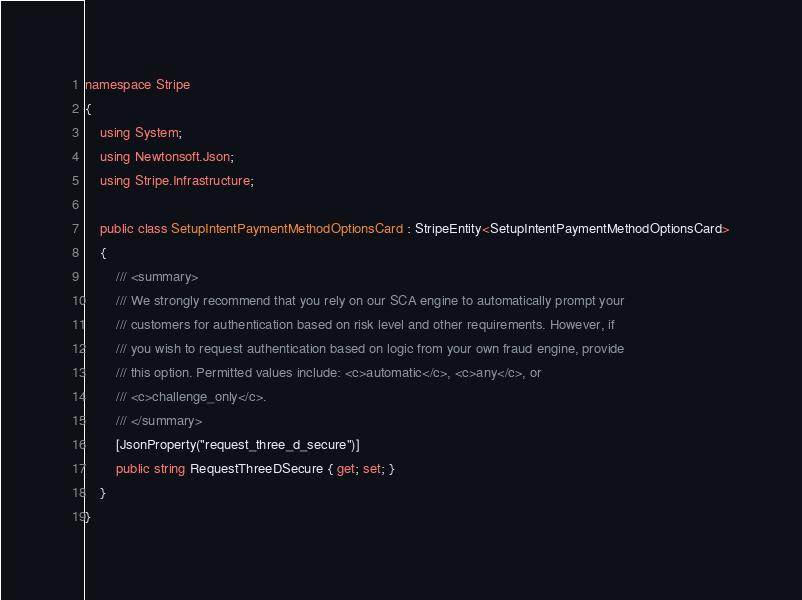<code> <loc_0><loc_0><loc_500><loc_500><_C#_>namespace Stripe
{
    using System;
    using Newtonsoft.Json;
    using Stripe.Infrastructure;

    public class SetupIntentPaymentMethodOptionsCard : StripeEntity<SetupIntentPaymentMethodOptionsCard>
    {
        /// <summary>
        /// We strongly recommend that you rely on our SCA engine to automatically prompt your
        /// customers for authentication based on risk level and other requirements. However, if
        /// you wish to request authentication based on logic from your own fraud engine, provide
        /// this option. Permitted values include: <c>automatic</c>, <c>any</c>, or
        /// <c>challenge_only</c>.
        /// </summary>
        [JsonProperty("request_three_d_secure")]
        public string RequestThreeDSecure { get; set; }
    }
}
</code> 